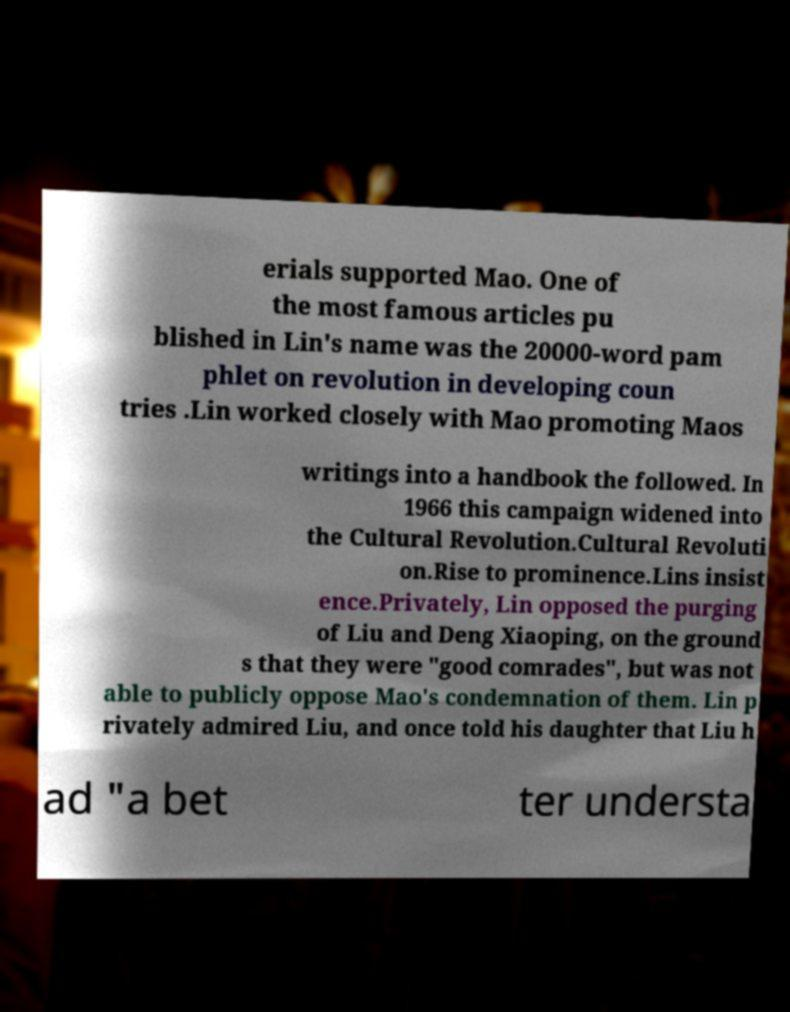I need the written content from this picture converted into text. Can you do that? erials supported Mao. One of the most famous articles pu blished in Lin's name was the 20000-word pam phlet on revolution in developing coun tries .Lin worked closely with Mao promoting Maos writings into a handbook the followed. In 1966 this campaign widened into the Cultural Revolution.Cultural Revoluti on.Rise to prominence.Lins insist ence.Privately, Lin opposed the purging of Liu and Deng Xiaoping, on the ground s that they were "good comrades", but was not able to publicly oppose Mao's condemnation of them. Lin p rivately admired Liu, and once told his daughter that Liu h ad "a bet ter understa 